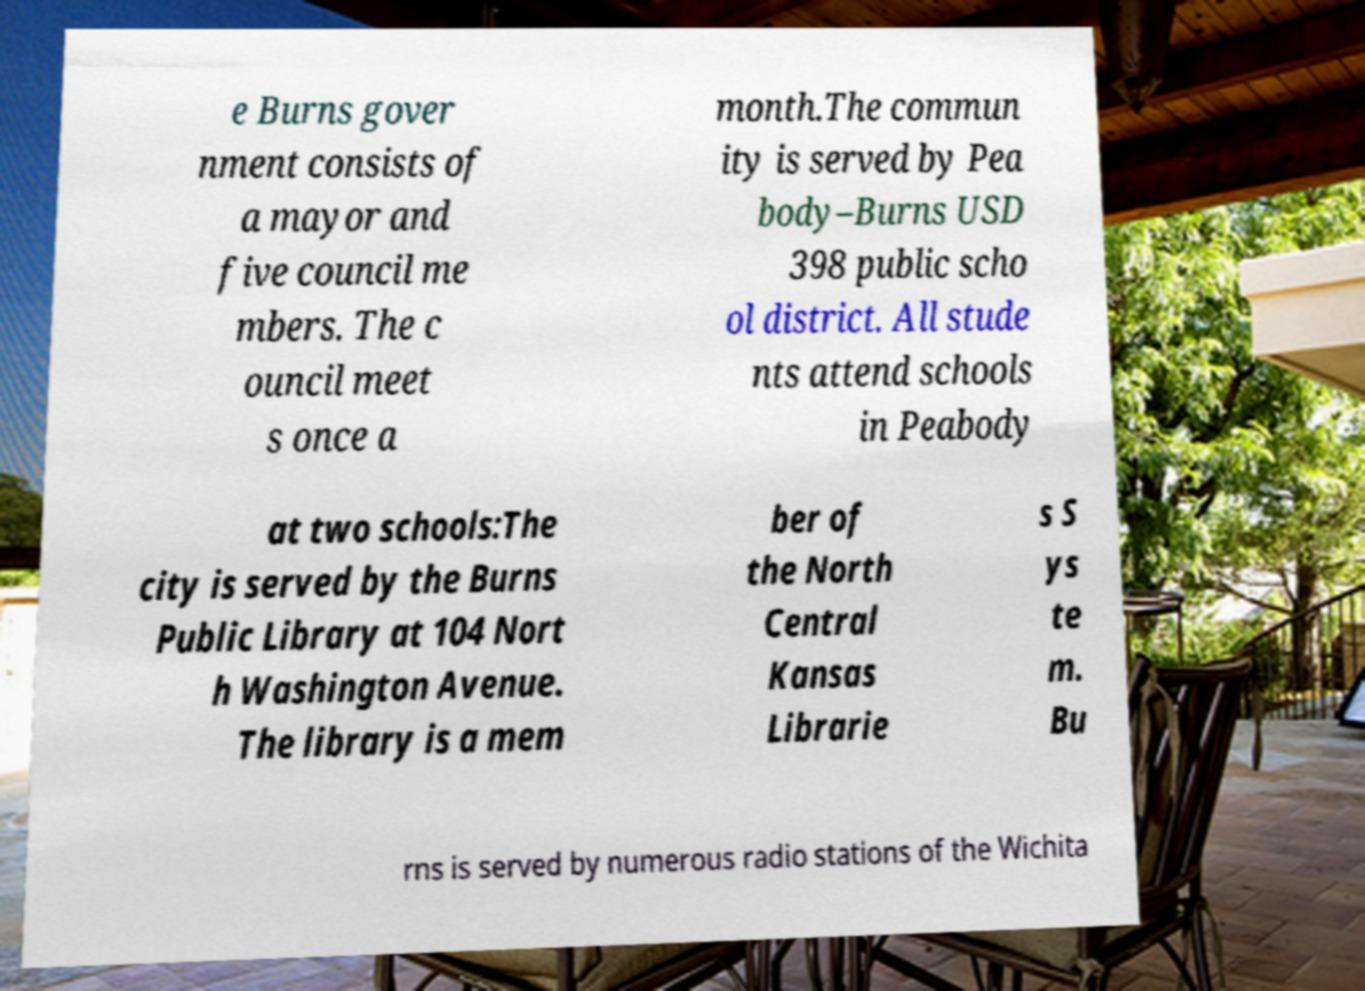Can you accurately transcribe the text from the provided image for me? e Burns gover nment consists of a mayor and five council me mbers. The c ouncil meet s once a month.The commun ity is served by Pea body–Burns USD 398 public scho ol district. All stude nts attend schools in Peabody at two schools:The city is served by the Burns Public Library at 104 Nort h Washington Avenue. The library is a mem ber of the North Central Kansas Librarie s S ys te m. Bu rns is served by numerous radio stations of the Wichita 